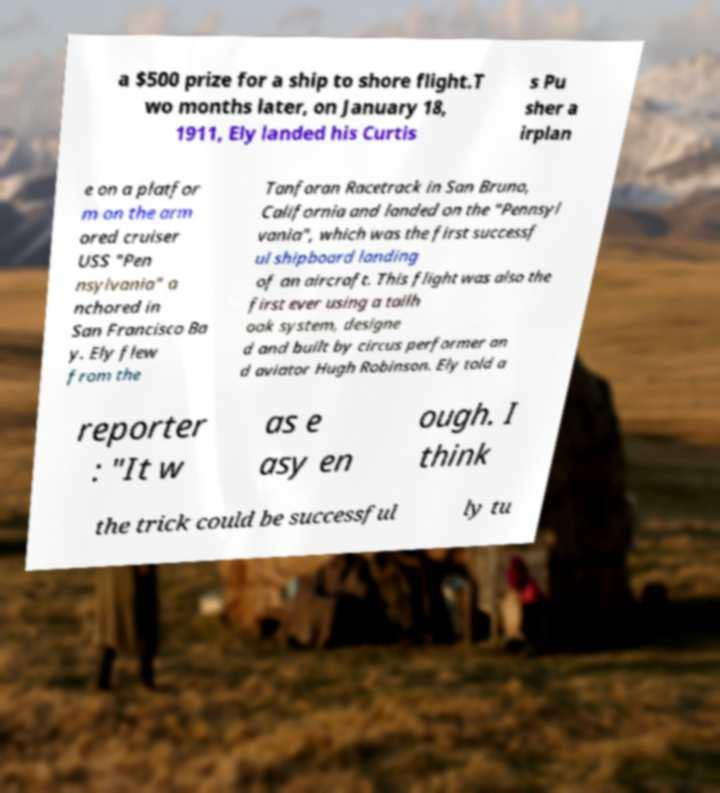Could you extract and type out the text from this image? a $500 prize for a ship to shore flight.T wo months later, on January 18, 1911, Ely landed his Curtis s Pu sher a irplan e on a platfor m on the arm ored cruiser USS "Pen nsylvania" a nchored in San Francisco Ba y. Ely flew from the Tanforan Racetrack in San Bruno, California and landed on the "Pennsyl vania", which was the first successf ul shipboard landing of an aircraft. This flight was also the first ever using a tailh ook system, designe d and built by circus performer an d aviator Hugh Robinson. Ely told a reporter : "It w as e asy en ough. I think the trick could be successful ly tu 